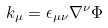<formula> <loc_0><loc_0><loc_500><loc_500>k _ { \mu } = \epsilon _ { \mu \nu } \nabla ^ { \nu } \Phi</formula> 